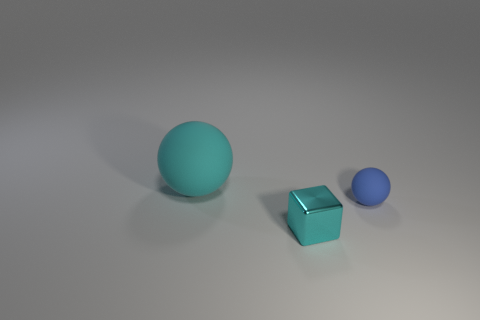Is there anything else that is the same size as the cyan matte ball?
Your answer should be compact. No. There is a object in front of the matte ball that is in front of the cyan matte object; what is its material?
Give a very brief answer. Metal. How many objects are either large red rubber blocks or tiny objects behind the metallic object?
Give a very brief answer. 1. The ball that is made of the same material as the blue thing is what size?
Offer a terse response. Large. Are there more blue things that are to the left of the small block than rubber things?
Ensure brevity in your answer.  No. What size is the object that is both on the left side of the small rubber thing and behind the small cyan object?
Provide a short and direct response. Large. Does the cyan object in front of the blue rubber sphere have the same size as the small rubber object?
Make the answer very short. Yes. There is a object that is behind the small cyan metallic cube and in front of the big sphere; what color is it?
Offer a terse response. Blue. There is a thing in front of the small sphere; what number of cyan metallic cubes are right of it?
Offer a terse response. 0. Do the tiny blue object and the big cyan object have the same shape?
Provide a short and direct response. Yes. 